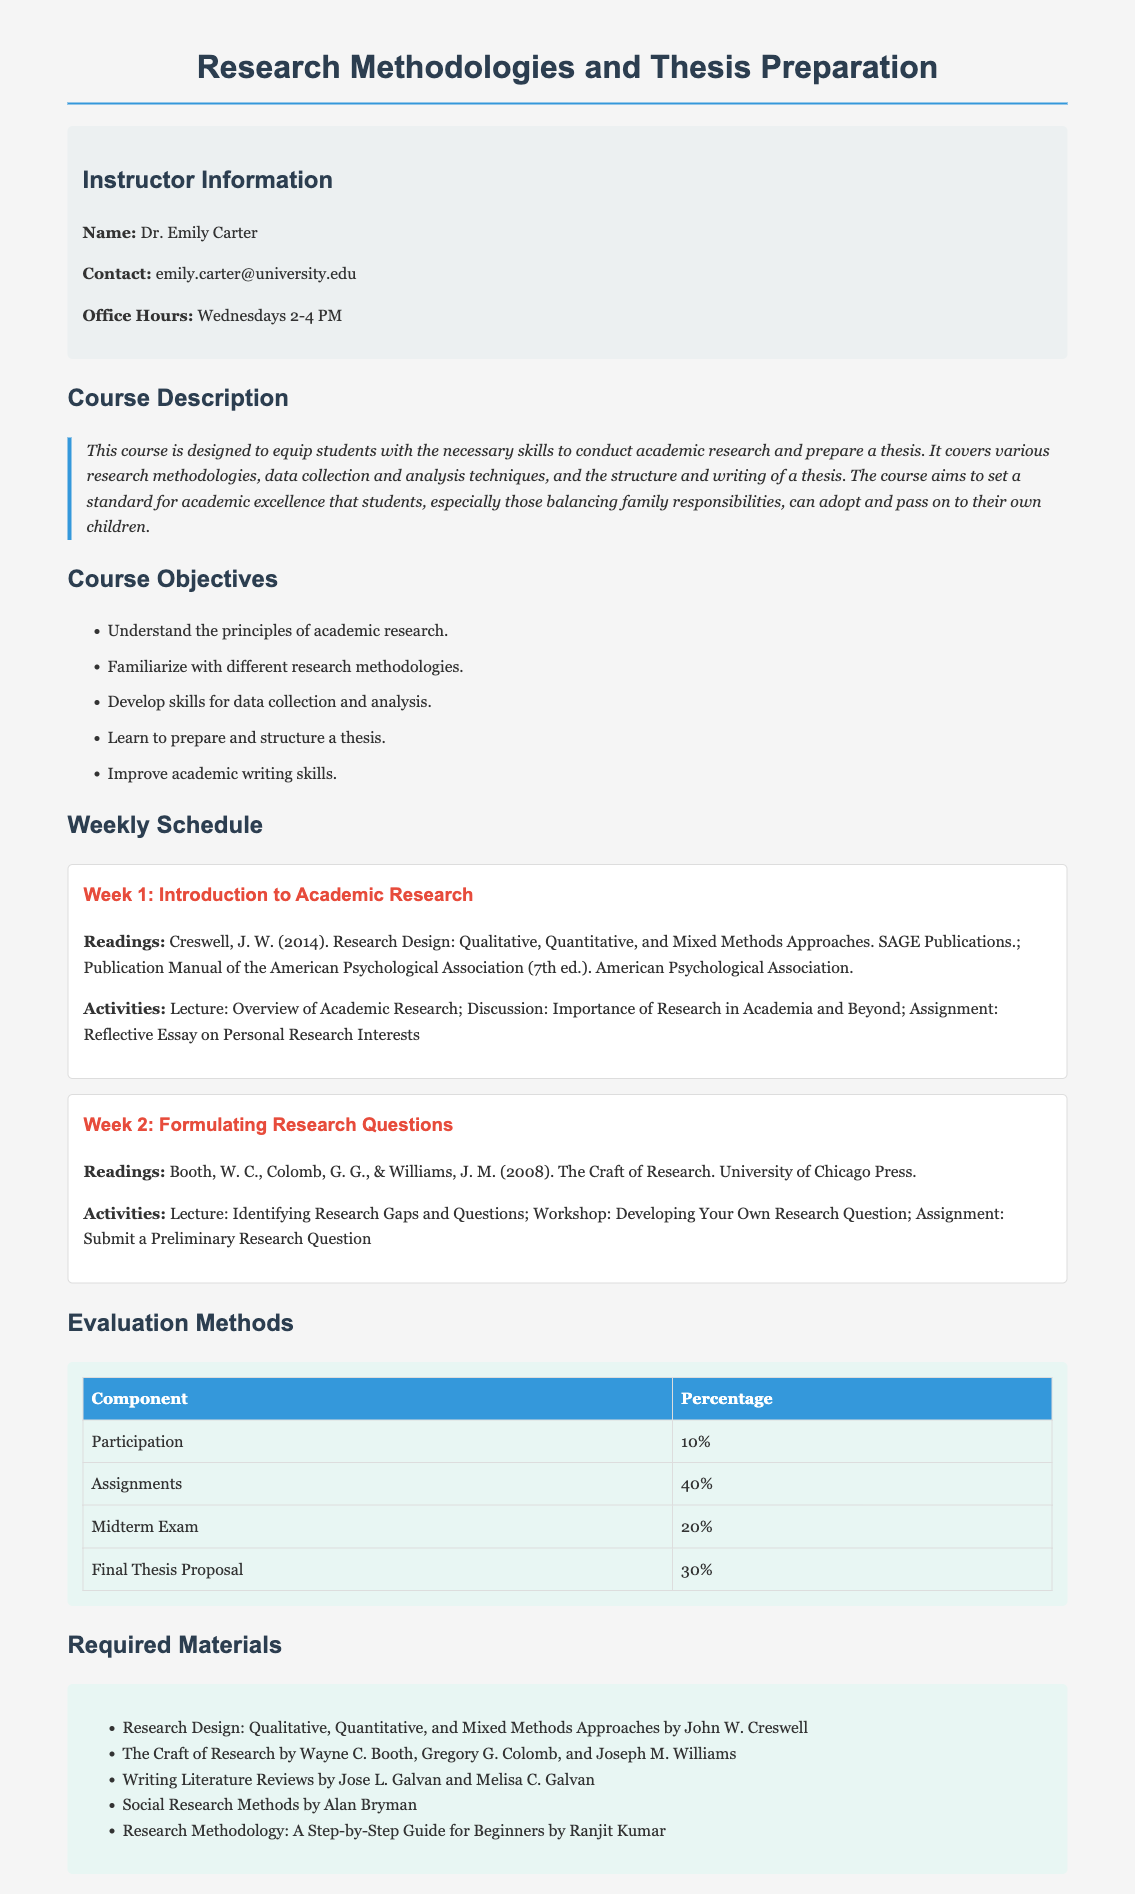What is the name of the instructor? The instructor's name is listed in the instructor information section of the document.
Answer: Dr. Emily Carter What percentage of the final grade is based on assignments? The percentage is stated in the evaluation methods table in the document.
Answer: 40% What is the title of the required reading by John W. Creswell? The title is mentioned in the required materials section of the document.
Answer: Research Design: Qualitative, Quantitative, and Mixed Methods Approaches What activity is assigned for Week 1? The assigned activity is provided under the activities section for Week 1.
Answer: Reflective Essay on Personal Research Interests How many weeks are detailed in the weekly schedule? The number of weeks can be determined by counting the week sections in the document.
Answer: 2 